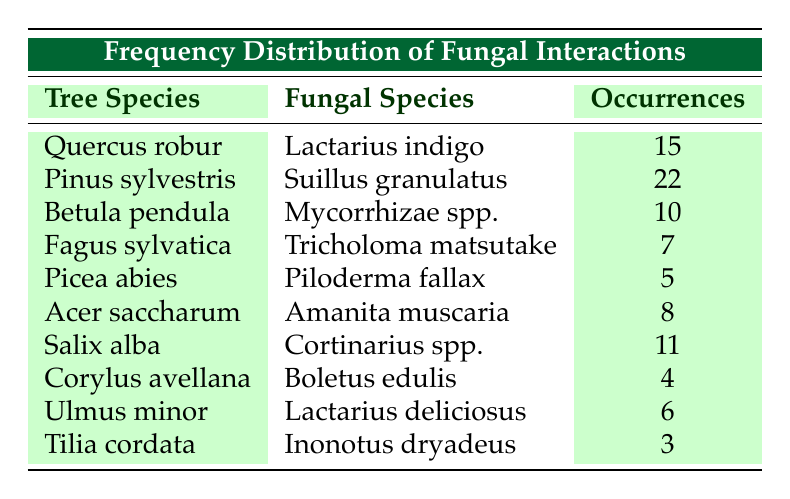What is the fungal species associated with Quercus robur? According to the table, the fungal species associated with Quercus robur is Lactarius indigo.
Answer: Lactarius indigo How many occurrences are associated with Pinus sylvestris? The table shows that there are 22 occurrences associated with Pinus sylvestris.
Answer: 22 What is the total number of occurrences for Betula pendula and Fagus sylvatica combined? To find the total, add the occurrences for both species: Betula pendula has 10 occurrences and Fagus sylvatica has 7 occurrences. Thus, 10 + 7 = 17.
Answer: 17 Is there a fungal species associated with Corylus avellana? Yes, there is a fungal species associated with Corylus avellana, which is Boletus edulis.
Answer: Yes Which tree species has the least number of occurrences, and how many are there? By examining the occurrences in the table, Tilia cordata has the least occurrences with a total of 3.
Answer: Tilia cordata, 3 What is the average number of occurrences across all tree species? First, add up all the occurrences: 15 + 22 + 10 + 7 + 5 + 8 + 11 + 4 + 6 + 3 = 87. Then, divide by the total number of tree species (10) to get the average: 87 / 10 = 8.7.
Answer: 8.7 Is Lactarius deliciosus associated with any tree species? Yes, Lactarius deliciosus is associated with Ulmus minor, according to the table.
Answer: Yes How many fungal species have more than 10 occurrences? The fungal species with more than 10 occurrences from the table are Suillus granulatus (22) and Lactarius indigo (15). Thus, there are 2 species.
Answer: 2 What is the difference in occurrences between the highest and lowest observed? The highest occurrences are 22 (Pinus sylvestris), and the lowest is 3 (Tilia cordata). To find the difference, subtract: 22 - 3 = 19.
Answer: 19 